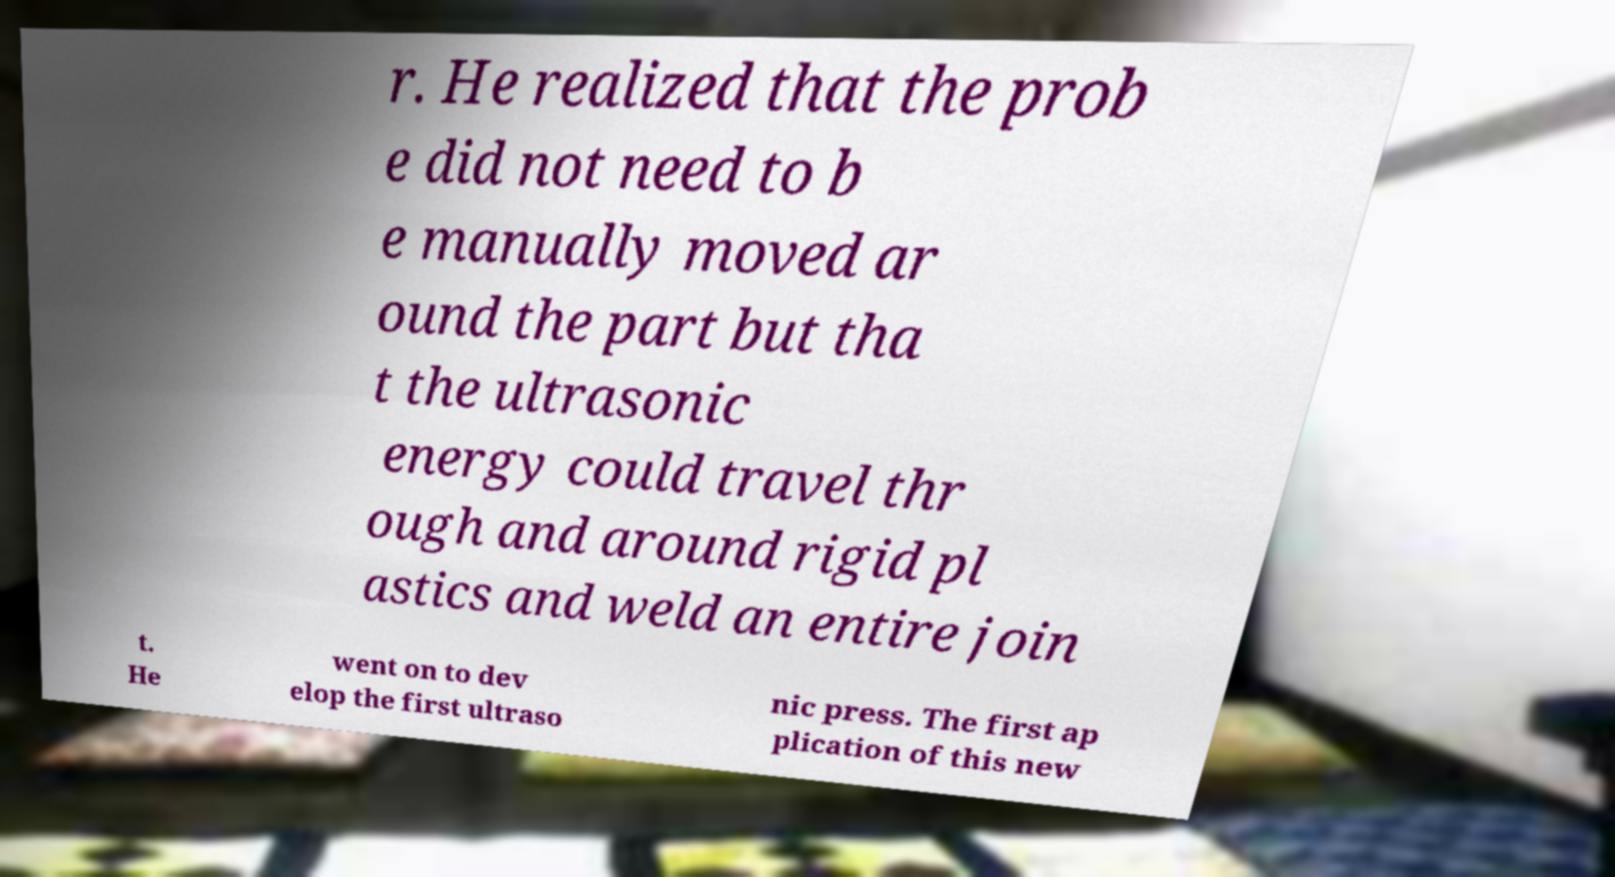Can you accurately transcribe the text from the provided image for me? r. He realized that the prob e did not need to b e manually moved ar ound the part but tha t the ultrasonic energy could travel thr ough and around rigid pl astics and weld an entire join t. He went on to dev elop the first ultraso nic press. The first ap plication of this new 